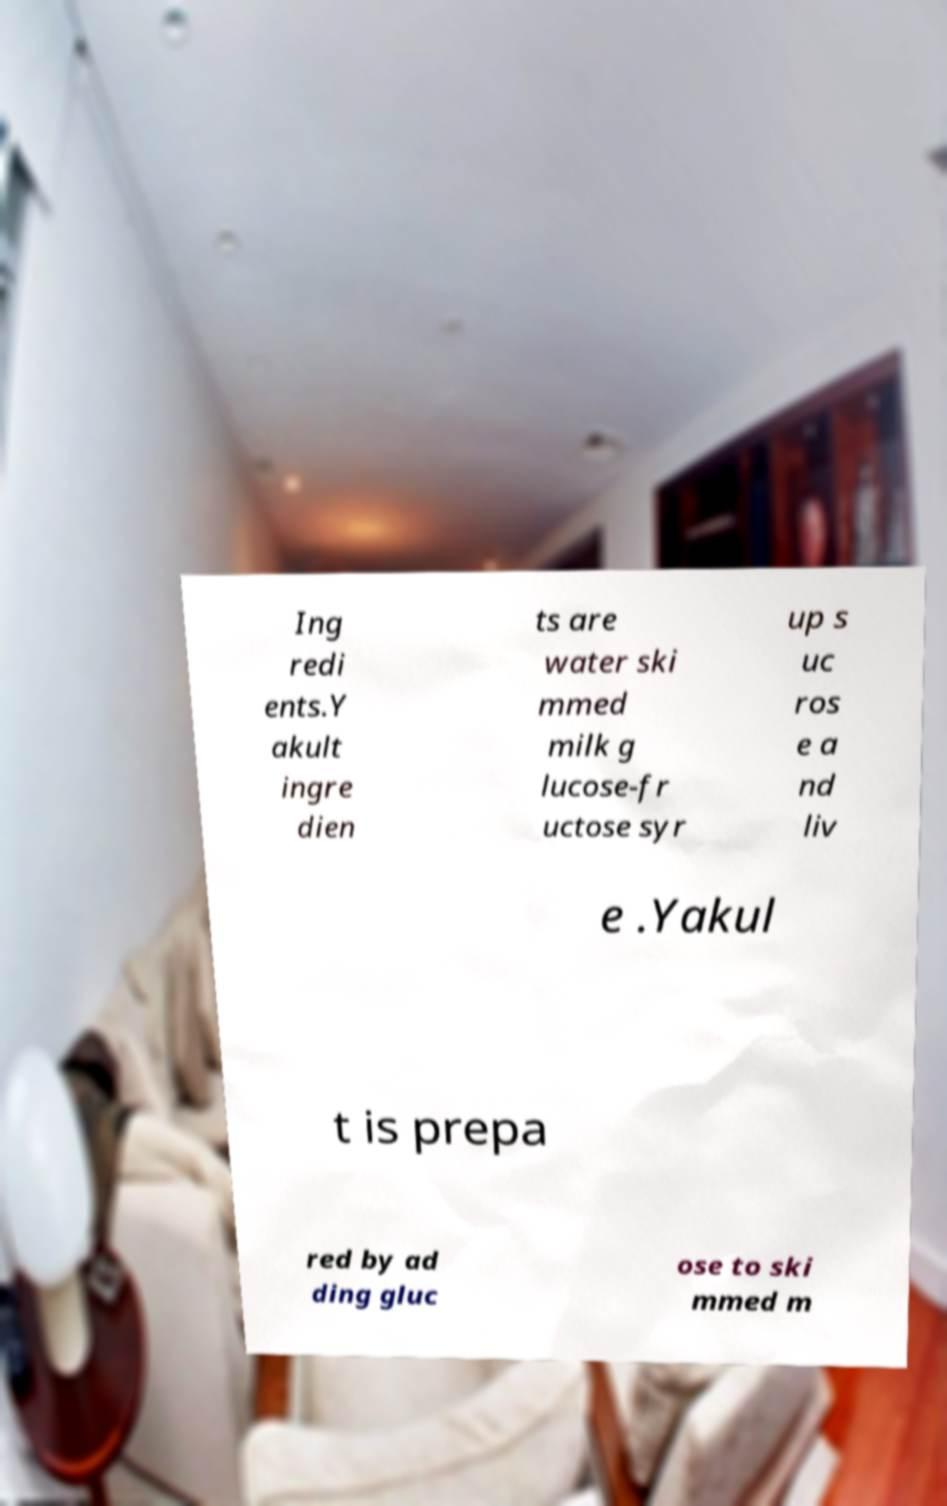There's text embedded in this image that I need extracted. Can you transcribe it verbatim? Ing redi ents.Y akult ingre dien ts are water ski mmed milk g lucose-fr uctose syr up s uc ros e a nd liv e .Yakul t is prepa red by ad ding gluc ose to ski mmed m 